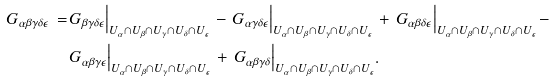Convert formula to latex. <formula><loc_0><loc_0><loc_500><loc_500>G _ { \alpha \beta \gamma \delta \epsilon } \, = \, & G _ { \beta \gamma \delta \epsilon } \Big | _ { U _ { \alpha } \cap U _ { \beta } \cap U _ { \gamma } \cap U _ { \delta } \cap U _ { \epsilon } } \, - \, G _ { \alpha \gamma \delta \epsilon } \Big | _ { U _ { \alpha } \cap U _ { \beta } \cap U _ { \gamma } \cap U _ { \delta } \cap U _ { \epsilon } } \, + \, G _ { \alpha \beta \delta \epsilon } \Big | _ { U _ { \alpha } \cap U _ { \beta } \cap U _ { \gamma } \cap U _ { \delta } \cap U _ { \epsilon } } \, - \\ & G _ { \alpha \beta \gamma \epsilon } \Big | _ { U _ { \alpha } \cap U _ { \beta } \cap U _ { \gamma } \cap U _ { \delta } \cap U _ { \epsilon } } \, + \, G _ { \alpha \beta \gamma \delta } \Big | _ { U _ { \alpha } \cap U _ { \beta } \cap U _ { \gamma } \cap U _ { \delta } \cap U _ { \epsilon } } .</formula> 